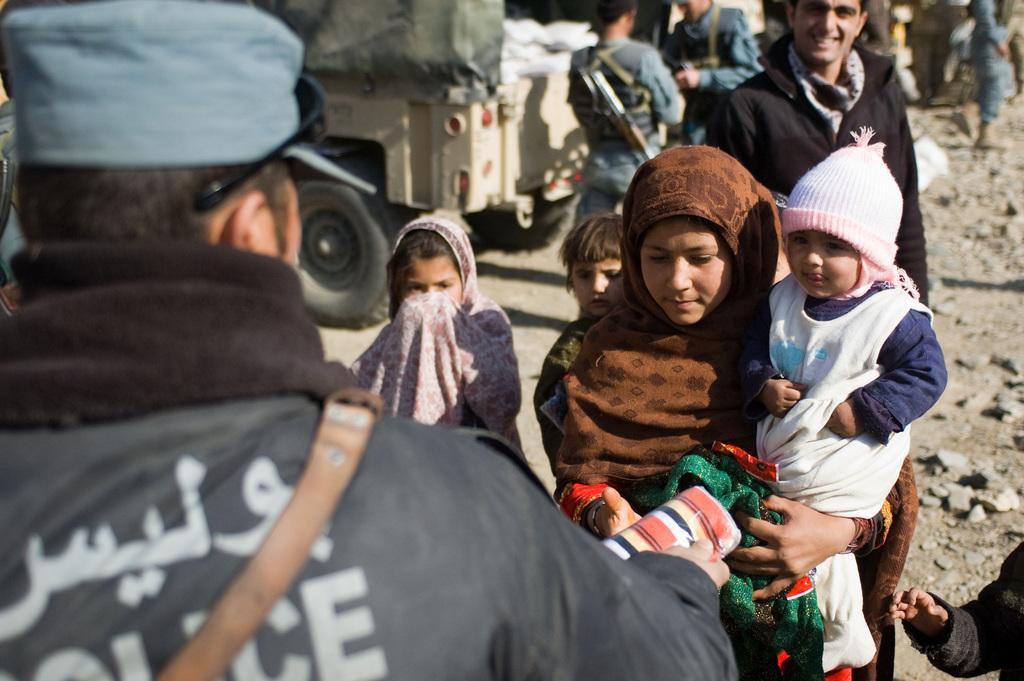How would you summarize this image in a sentence or two? In this image there are persons standing. On the ground there are stones. At the top there is a vehicle. In the center there is a woman standing and holding a baby in her arms and there is an object in the hand of the woman which is green in colour and there is a person standing and smiling. In the front there is a person wearing a jacket with some text written on it and holding an object in his hand. 